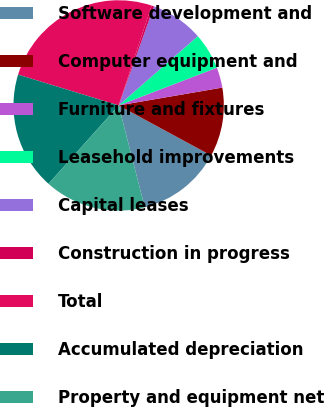<chart> <loc_0><loc_0><loc_500><loc_500><pie_chart><fcel>Software development and<fcel>Computer equipment and<fcel>Furniture and fixtures<fcel>Leasehold improvements<fcel>Capital leases<fcel>Construction in progress<fcel>Total<fcel>Accumulated depreciation<fcel>Property and equipment net<nl><fcel>13.11%<fcel>10.61%<fcel>3.12%<fcel>5.61%<fcel>8.11%<fcel>0.36%<fcel>25.35%<fcel>18.11%<fcel>15.61%<nl></chart> 